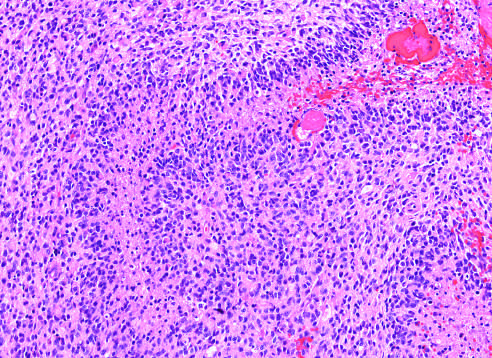s glioblastoma a densely cellular tumor with necrosis and pseudo-palisading of tumor cell nuclei along the edge of the necrotic zone?
Answer the question using a single word or phrase. Yes 